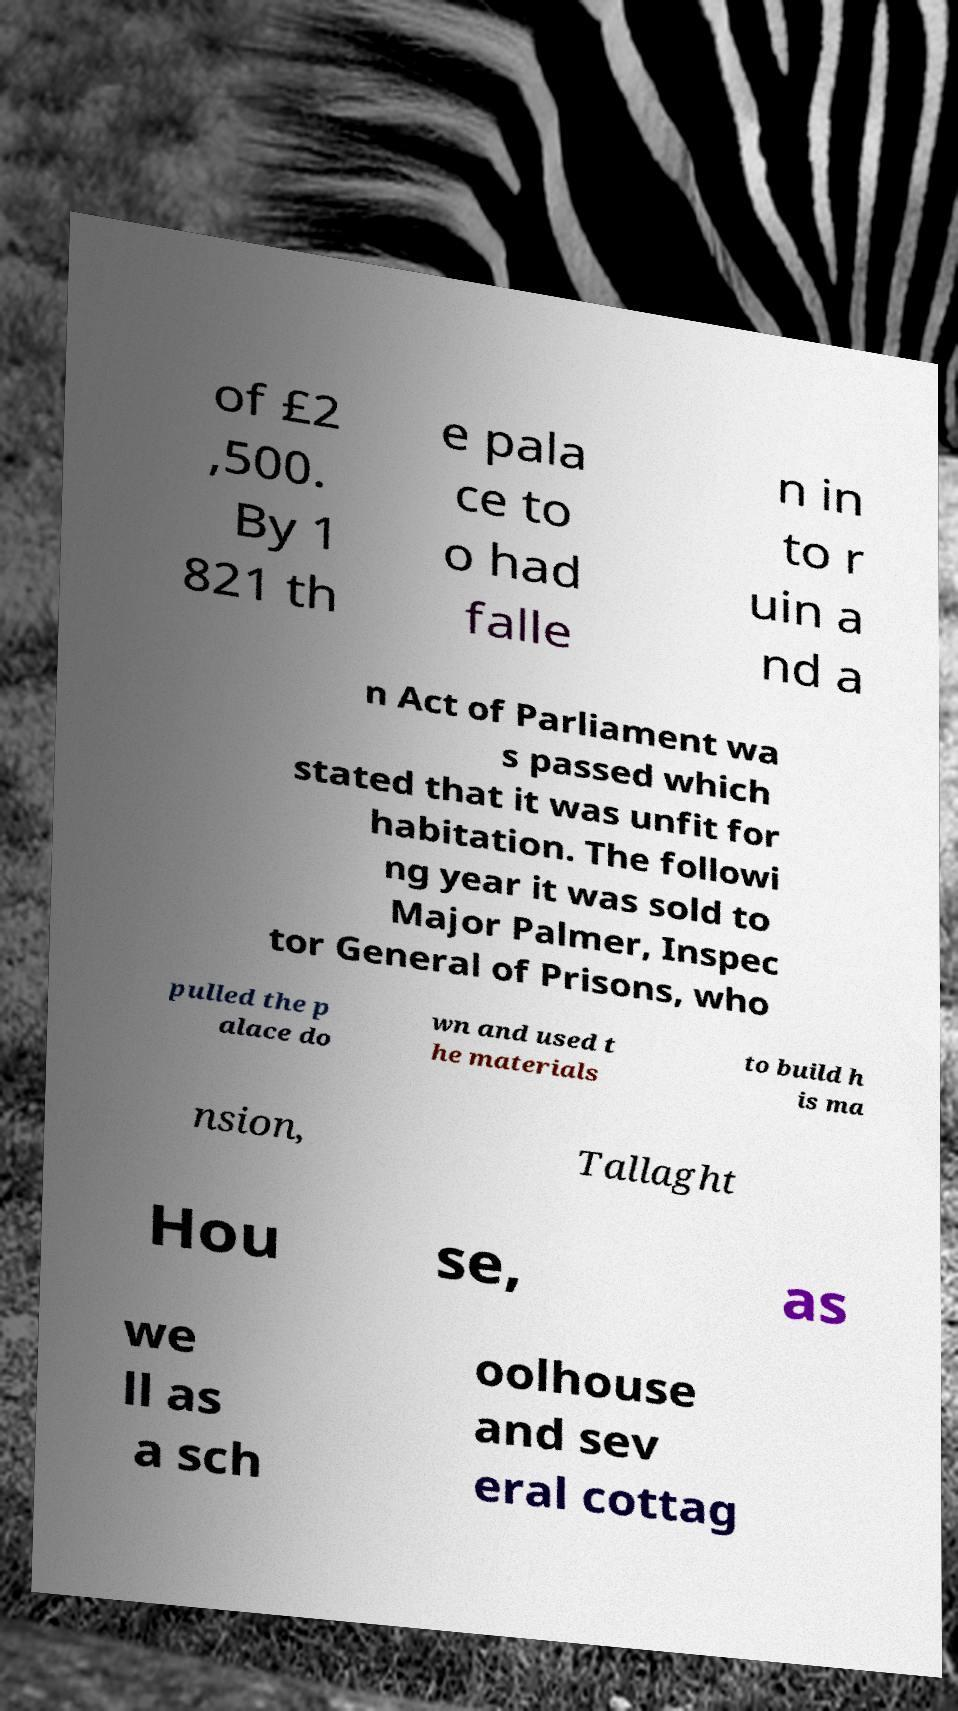For documentation purposes, I need the text within this image transcribed. Could you provide that? of £2 ,500. By 1 821 th e pala ce to o had falle n in to r uin a nd a n Act of Parliament wa s passed which stated that it was unfit for habitation. The followi ng year it was sold to Major Palmer, Inspec tor General of Prisons, who pulled the p alace do wn and used t he materials to build h is ma nsion, Tallaght Hou se, as we ll as a sch oolhouse and sev eral cottag 